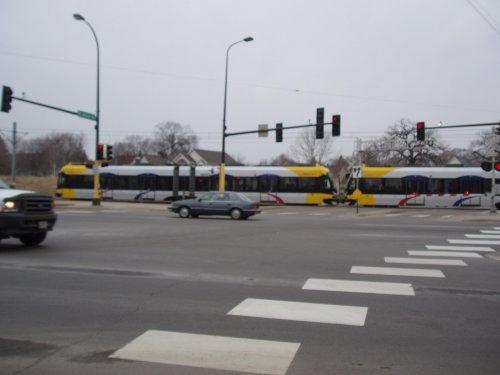Can you read the number plate of the left most car?
Answer briefly. No. How many buses are in the photo?
Quick response, please. 2. Where are the traffic lights?
Be succinct. On poles. 